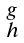Convert formula to latex. <formula><loc_0><loc_0><loc_500><loc_500>\begin{smallmatrix} g \\ h \end{smallmatrix}</formula> 